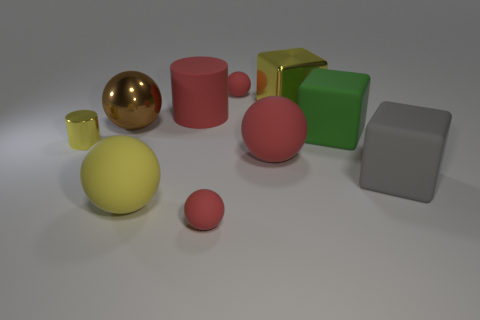Subtract all green cylinders. How many red balls are left? 3 Subtract 1 blocks. How many blocks are left? 2 Subtract all yellow balls. How many balls are left? 4 Subtract all yellow spheres. How many spheres are left? 4 Subtract all yellow spheres. Subtract all gray cubes. How many spheres are left? 4 Subtract all cylinders. How many objects are left? 8 Add 4 green rubber balls. How many green rubber balls exist? 4 Subtract 0 purple balls. How many objects are left? 10 Subtract all small spheres. Subtract all brown metallic balls. How many objects are left? 7 Add 1 yellow metal things. How many yellow metal things are left? 3 